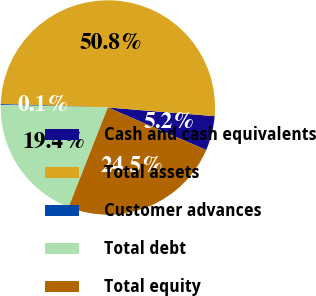Convert chart. <chart><loc_0><loc_0><loc_500><loc_500><pie_chart><fcel>Cash and cash equivalents<fcel>Total assets<fcel>Customer advances<fcel>Total debt<fcel>Total equity<nl><fcel>5.21%<fcel>50.79%<fcel>0.14%<fcel>19.4%<fcel>24.46%<nl></chart> 